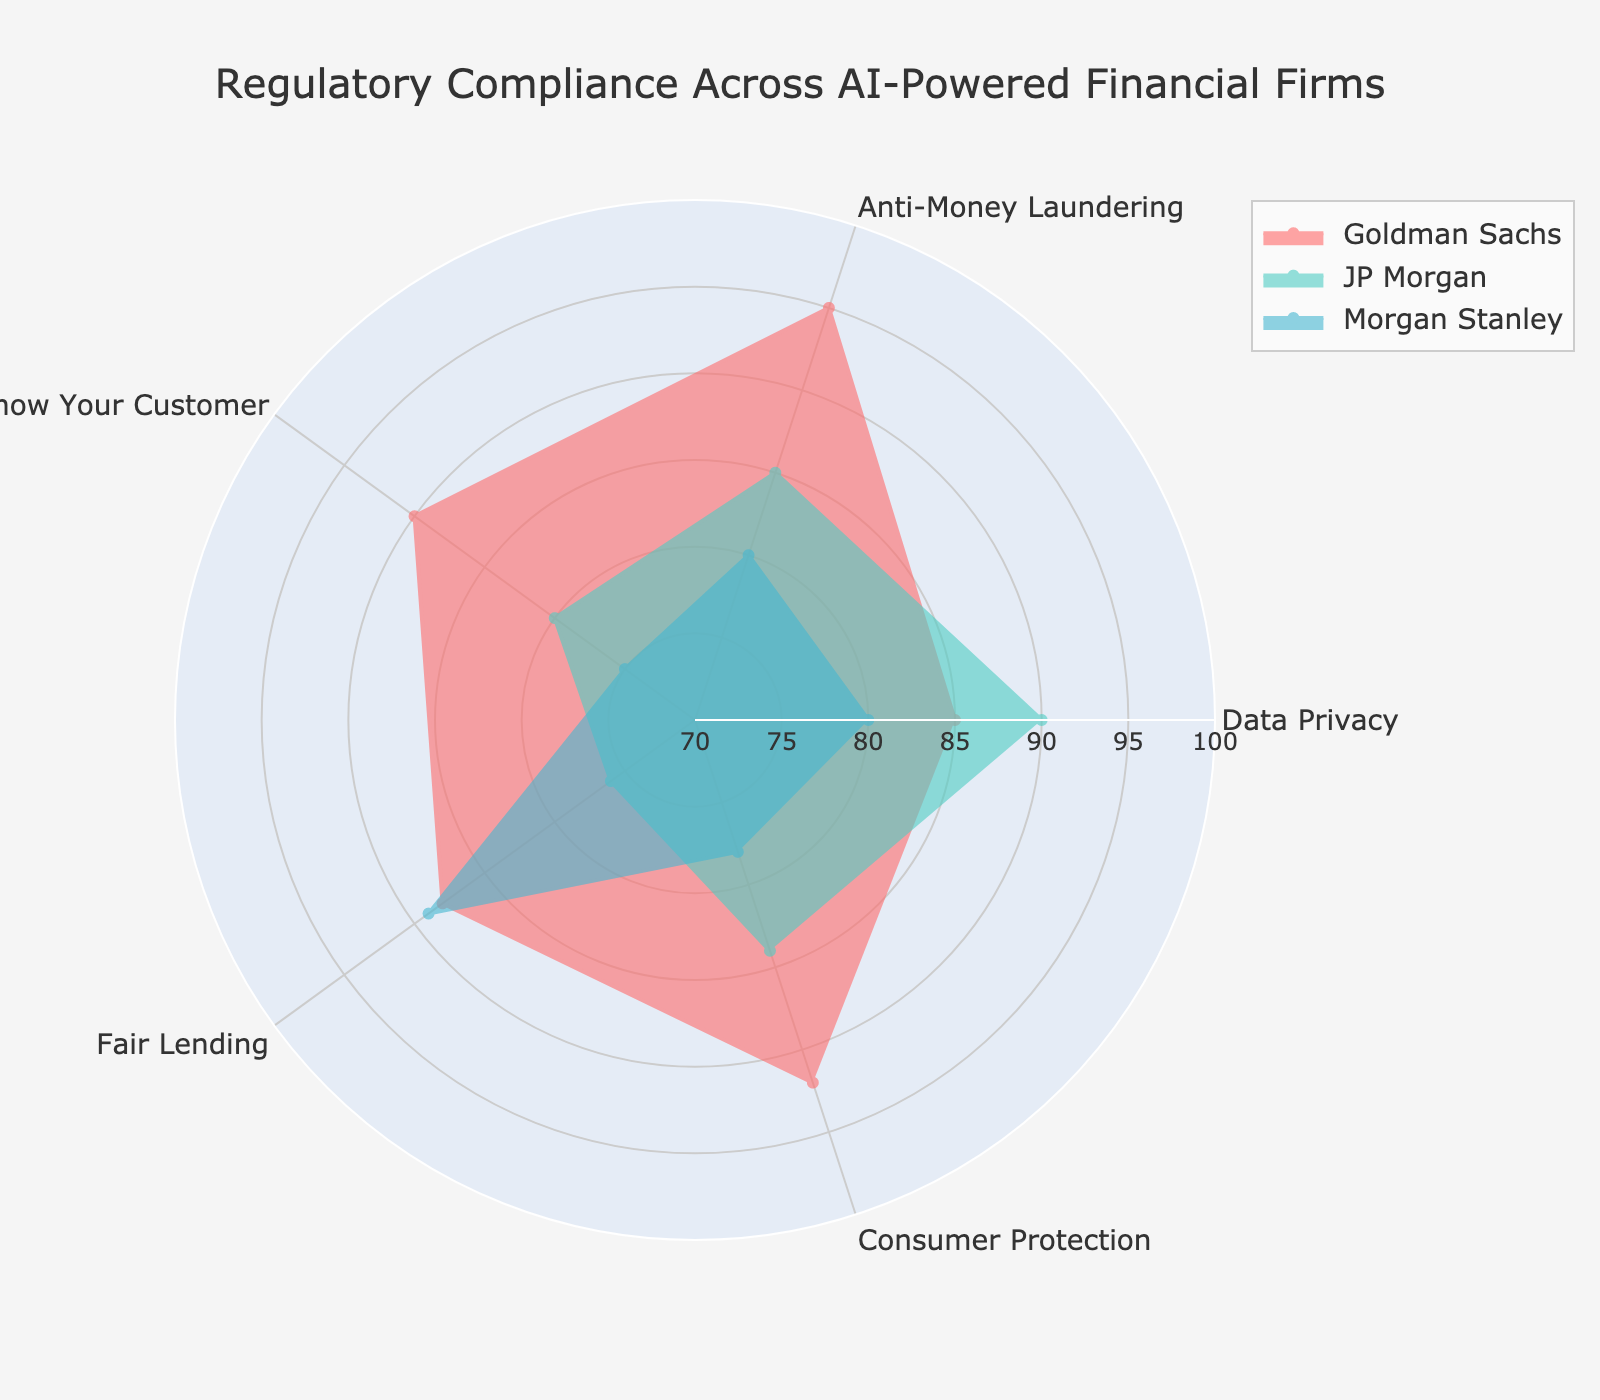What is the title of the radar chart? The title of the chart is often placed at the top center and it directly states the main subject of the visualization. By reading the title, we can understand what the chart is about.
Answer: Regulatory Compliance Across AI-Powered Financial Firms Which parameter has the highest compliance score for Goldman Sachs? Look for the points on Goldman Sachs' radar plot and identify which one is at the maximum distance from the center. The highest point corresponds to the highest compliance score.
Answer: Anti-Money Laundering What is the average compliance score for JP Morgan across all parameters? Sum the compliance scores for JP Morgan across all parameters and divide by the number of parameters (5). The calculations are (90 + 85 + 80 + 76 + 84) / 5.
Answer: 83 Which company has the lowest score in Know Your Customer? Inspect the points corresponding to the Know Your Customer parameter for each company and identify the smallest value.
Answer: Morgan Stanley Are there any two companies that have the same compliance score for any parameter? Check each parameter and compare the compliance scores for all three companies to see if any two companies share the same score.
Answer: No Compare the Consumer Protection scores between Goldman Sachs and Morgan Stanley. Which one is higher and by how much? Identify the Consumer Protection scores for both Goldman Sachs and Morgan Stanley and subtract the smaller value from the larger value. Specifically, compare 92 (Goldman Sachs) and 78 (Morgan Stanley).
Answer: Goldman Sachs by 14 What is the range of the compliance scores for Fair Lending across all companies? Find the highest and lowest compliance scores for the Fair Lending parameter among the companies and calculate the difference between them. The highest is 89 (Morgan Stanley), and the lowest is 76 (JP Morgan).
Answer: 13 Which parameter has the most balanced compliance scores across all companies, and what is this range? To determine balance, look for the parameter where the compliance scores of all companies are closest to each other. Calculate the range (difference between highest and lowest score) for each parameter. The Consumer Protection parameter has the scores 92, 84, and 78, giving a range of 14.
Answer: Consumer Protection, range is 14 Between Goldman Sachs and JP Morgan, which company generally has better compliance scores? Consider the average scores across all parameters for each company to answer this. Calculate the average score for both companies. For Goldman Sachs: (85 + 95 + 90 + 88 + 92) / 5 = 90. For JP Morgan: (90 + 85 + 80 + 76 + 84) / 5 = 83.
Answer: Goldman Sachs By how many points does the Anti-Money Laundering compliance score for JP Morgan differ from the Data Privacy compliance score for Morgan Stanley? Subtract Morgan Stanley’s Data Privacy score from JP Morgan’s Anti-Money Laundering score. Specifically, 85 (JP Morgan) - 80 (Morgan Stanley).
Answer: 5 